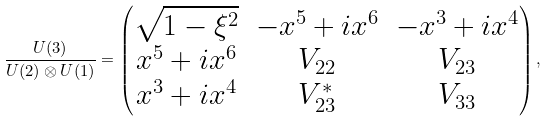Convert formula to latex. <formula><loc_0><loc_0><loc_500><loc_500>\frac { U ( 3 ) } { U ( 2 ) \otimes U ( 1 ) } = \begin{pmatrix} \sqrt { 1 - \xi ^ { 2 } } & - x ^ { 5 } + i x ^ { 6 } & - x ^ { 3 } + i x ^ { 4 } \\ x ^ { 5 } + i x ^ { 6 } & V _ { 2 2 } & V _ { 2 3 } \\ x ^ { 3 } + i x ^ { 4 } & V _ { 2 3 } ^ { * } & V _ { 3 3 } \end{pmatrix} ,</formula> 